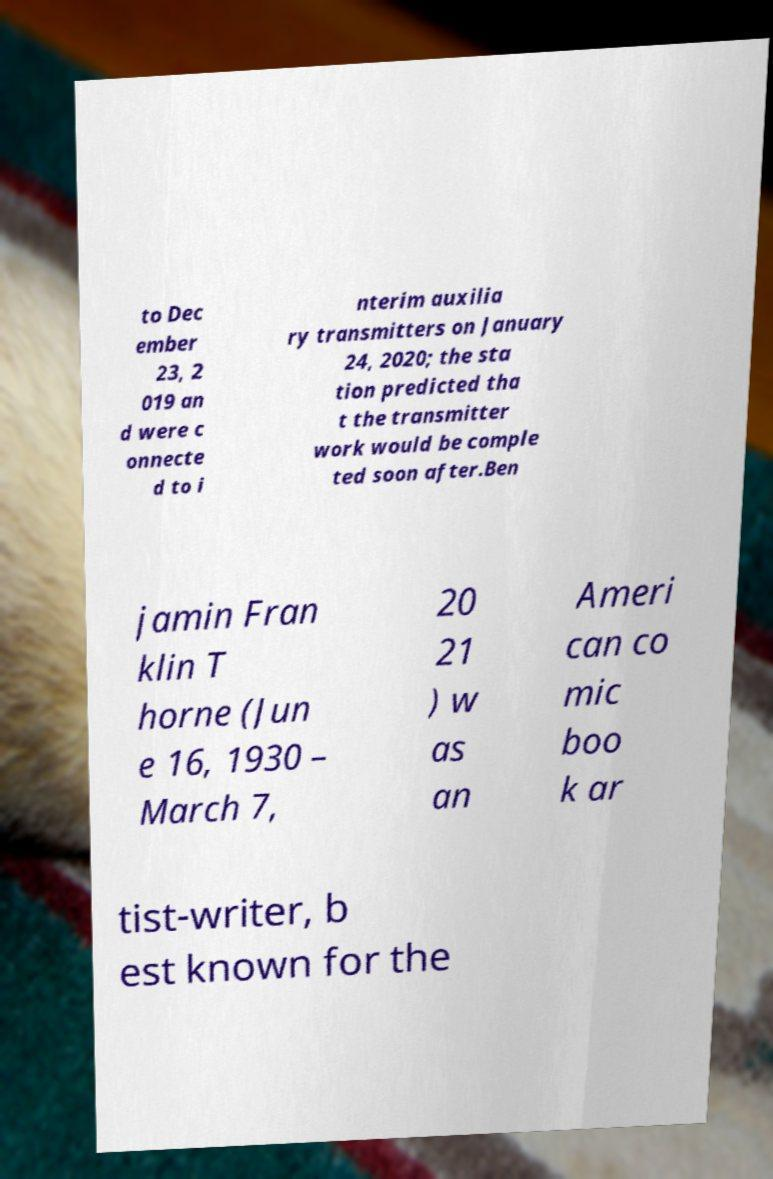Can you accurately transcribe the text from the provided image for me? to Dec ember 23, 2 019 an d were c onnecte d to i nterim auxilia ry transmitters on January 24, 2020; the sta tion predicted tha t the transmitter work would be comple ted soon after.Ben jamin Fran klin T horne (Jun e 16, 1930 – March 7, 20 21 ) w as an Ameri can co mic boo k ar tist-writer, b est known for the 